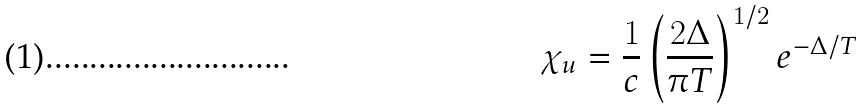<formula> <loc_0><loc_0><loc_500><loc_500>\chi _ { u } = \frac { 1 } { c } \left ( \frac { 2 \Delta } { \pi T } \right ) ^ { 1 / 2 } e ^ { - \Delta / T }</formula> 